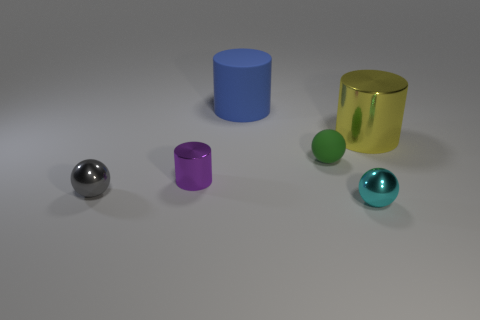What number of objects are both in front of the big yellow cylinder and to the right of the tiny gray sphere?
Your response must be concise. 3. Does the green matte object have the same size as the purple metallic cylinder?
Make the answer very short. Yes. There is a metallic cylinder that is right of the green object; is its size the same as the big blue rubber thing?
Your answer should be compact. Yes. The metallic cylinder on the right side of the purple shiny object is what color?
Make the answer very short. Yellow. How many large cylinders are there?
Offer a terse response. 2. There is a large yellow thing that is the same material as the small gray ball; what shape is it?
Give a very brief answer. Cylinder. There is a cylinder that is in front of the green rubber ball; is its color the same as the metallic ball behind the tiny cyan sphere?
Keep it short and to the point. No. Is the number of cyan metal things that are on the left side of the big blue thing the same as the number of small gray balls?
Offer a very short reply. No. There is a small purple thing; how many large blue cylinders are behind it?
Ensure brevity in your answer.  1. The gray metal object is what size?
Give a very brief answer. Small. 